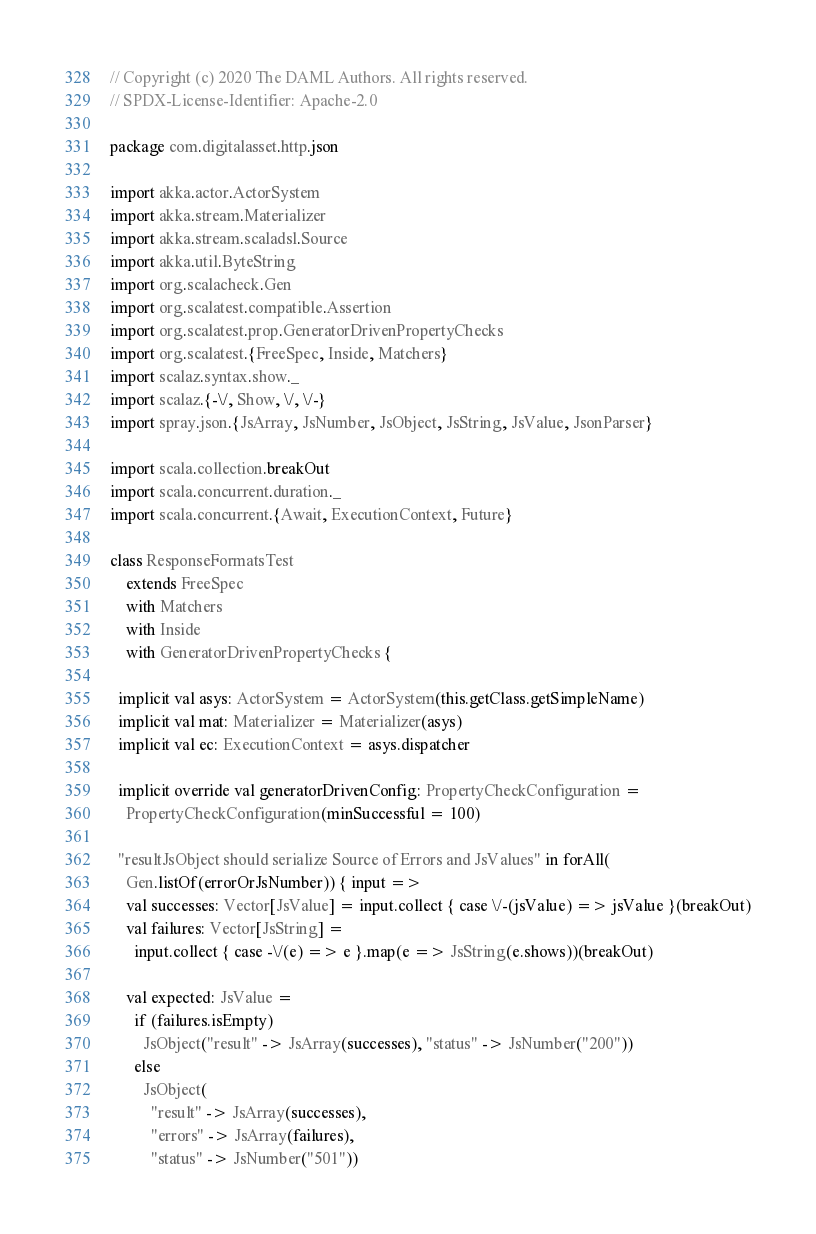Convert code to text. <code><loc_0><loc_0><loc_500><loc_500><_Scala_>// Copyright (c) 2020 The DAML Authors. All rights reserved.
// SPDX-License-Identifier: Apache-2.0

package com.digitalasset.http.json

import akka.actor.ActorSystem
import akka.stream.Materializer
import akka.stream.scaladsl.Source
import akka.util.ByteString
import org.scalacheck.Gen
import org.scalatest.compatible.Assertion
import org.scalatest.prop.GeneratorDrivenPropertyChecks
import org.scalatest.{FreeSpec, Inside, Matchers}
import scalaz.syntax.show._
import scalaz.{-\/, Show, \/, \/-}
import spray.json.{JsArray, JsNumber, JsObject, JsString, JsValue, JsonParser}

import scala.collection.breakOut
import scala.concurrent.duration._
import scala.concurrent.{Await, ExecutionContext, Future}

class ResponseFormatsTest
    extends FreeSpec
    with Matchers
    with Inside
    with GeneratorDrivenPropertyChecks {

  implicit val asys: ActorSystem = ActorSystem(this.getClass.getSimpleName)
  implicit val mat: Materializer = Materializer(asys)
  implicit val ec: ExecutionContext = asys.dispatcher

  implicit override val generatorDrivenConfig: PropertyCheckConfiguration =
    PropertyCheckConfiguration(minSuccessful = 100)

  "resultJsObject should serialize Source of Errors and JsValues" in forAll(
    Gen.listOf(errorOrJsNumber)) { input =>
    val successes: Vector[JsValue] = input.collect { case \/-(jsValue) => jsValue }(breakOut)
    val failures: Vector[JsString] =
      input.collect { case -\/(e) => e }.map(e => JsString(e.shows))(breakOut)

    val expected: JsValue =
      if (failures.isEmpty)
        JsObject("result" -> JsArray(successes), "status" -> JsNumber("200"))
      else
        JsObject(
          "result" -> JsArray(successes),
          "errors" -> JsArray(failures),
          "status" -> JsNumber("501"))
</code> 